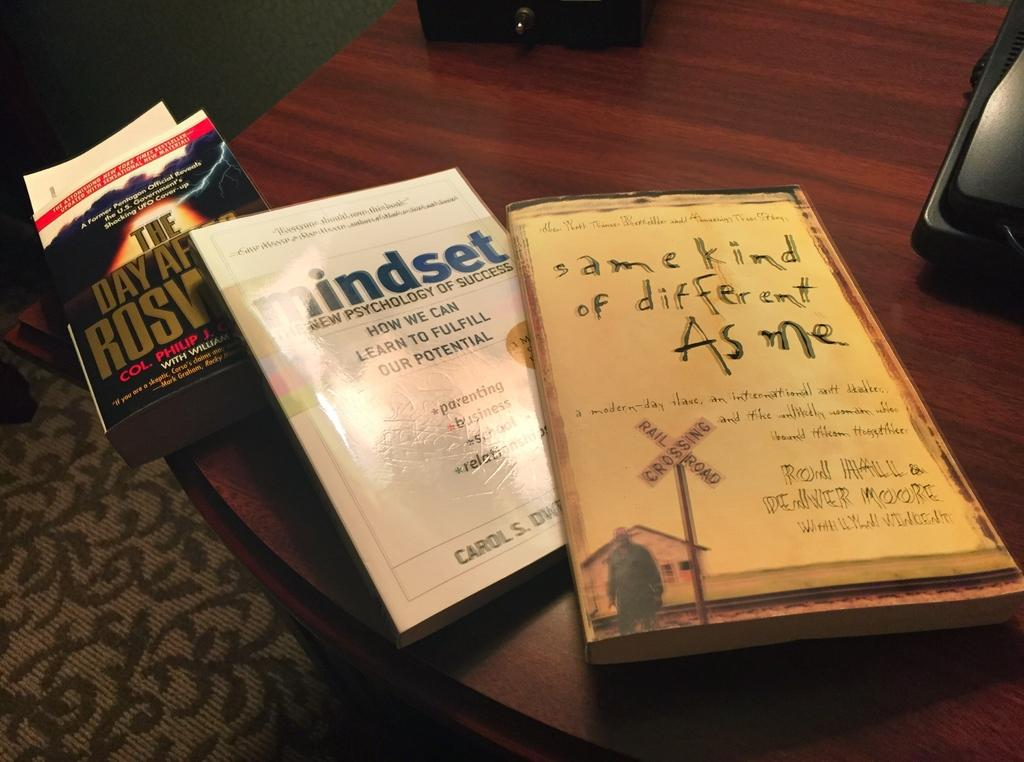<image>
Create a compact narrative representing the image presented. a book about mindset next to some other books 